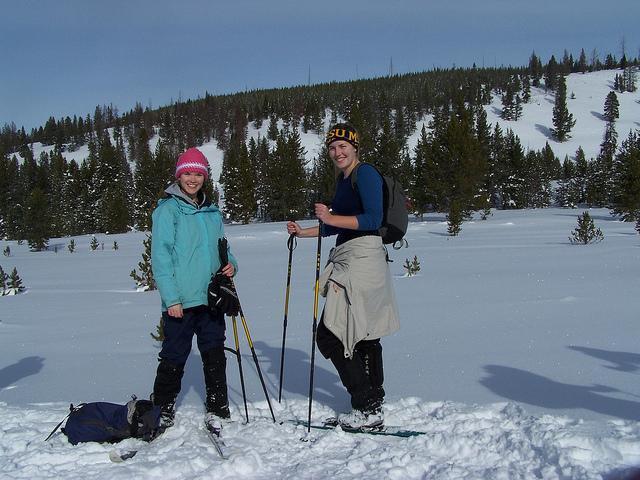How many people are wearing eye protection?
Give a very brief answer. 0. How many people are visible?
Give a very brief answer. 2. How many backpacks are in the picture?
Give a very brief answer. 2. 